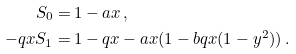Convert formula to latex. <formula><loc_0><loc_0><loc_500><loc_500>S _ { 0 } = & \, 1 - a x \, , \\ - q x S _ { 1 } = & \, 1 - q x - a x ( 1 - b q x ( 1 - y ^ { 2 } ) ) \, .</formula> 